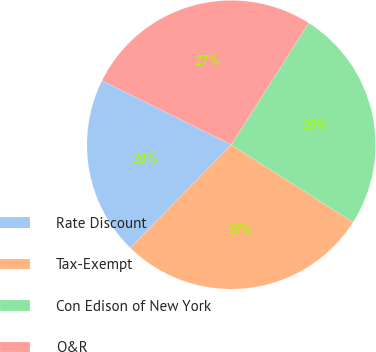<chart> <loc_0><loc_0><loc_500><loc_500><pie_chart><fcel>Rate Discount<fcel>Tax-Exempt<fcel>Con Edison of New York<fcel>O&R<nl><fcel>20.0%<fcel>28.33%<fcel>25.0%<fcel>26.67%<nl></chart> 